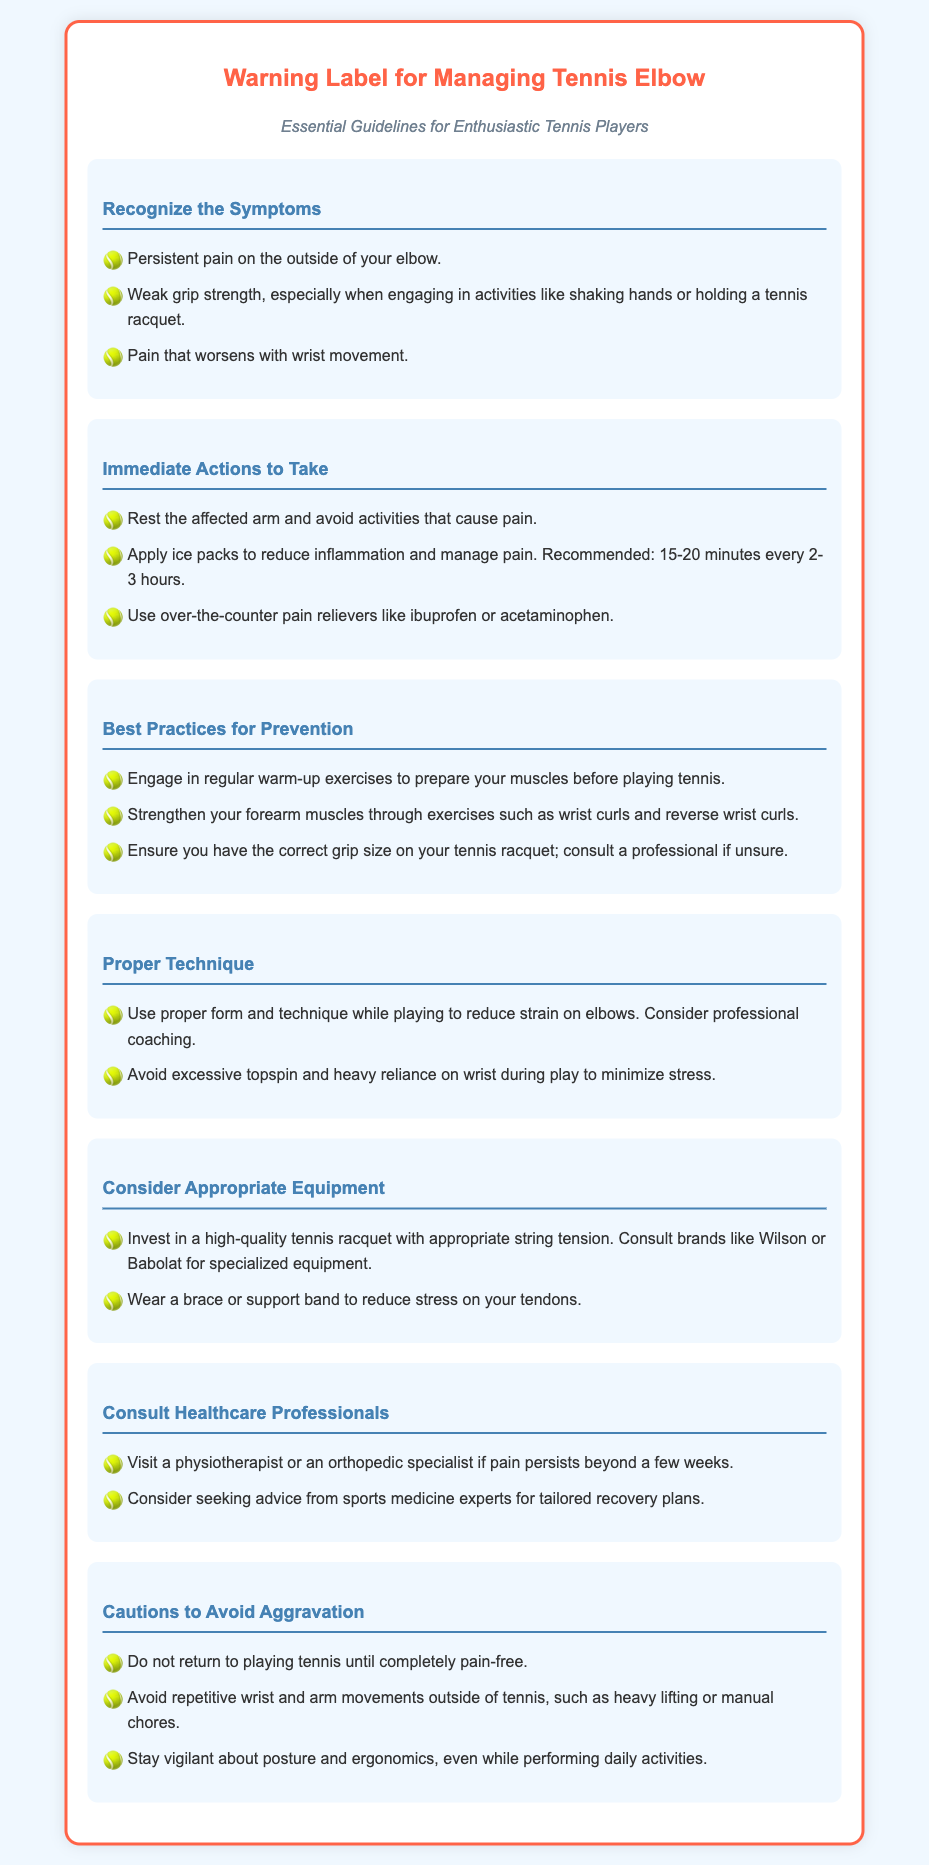What are the symptoms of tennis elbow? The symptoms are listed in the "Recognize the Symptoms" section, including persistent pain on the outside of the elbow, weak grip strength, and worsening pain with wrist movement.
Answer: Persistent pain on the outside of your elbow, weak grip strength, pain that worsens with wrist movement What immediate action should you take if you have tennis elbow? The "Immediate Actions to Take" section provides suggestions like resting the arm, applying ice, and using over-the-counter pain relievers.
Answer: Rest the affected arm, apply ice packs, use over-the-counter pain relievers Name one best practice for preventing tennis elbow. The "Best Practices for Prevention" section mentions several practices; one example includes engaging in regular warm-up exercises.
Answer: Engage in regular warm-up exercises What should you consider about your tennis racquet? The "Consider Appropriate Equipment" section suggests consulting brands and checking the grip size on your racquet.
Answer: Ensure you have the correct grip size; consult a professional What is advised if pain persists beyond a few weeks? The "Consult Healthcare Professionals" section indicates the need to visit a physiotherapist or orthopedic specialist.
Answer: Visit a physiotherapist or an orthopedic specialist What type of movements should be avoided to prevent aggravation? The "Cautions to Avoid Aggravation" section lists repetitive wrist and arm movements, among others.
Answer: Avoid repetitive wrist and arm movements How long should you wait before returning to tennis? The "Cautions to Avoid Aggravation" section states that one should not return until completely pain-free.
Answer: Completely pain-free What equipment can help reduce stress on tendons? The "Consider Appropriate Equipment" section suggests wearing a brace or support band.
Answer: Wear a brace or support band What type of professional might give tailored recovery plans? The "Consult Healthcare Professionals" section mentions sports medicine experts for tailored recovery plans.
Answer: Sports medicine experts 